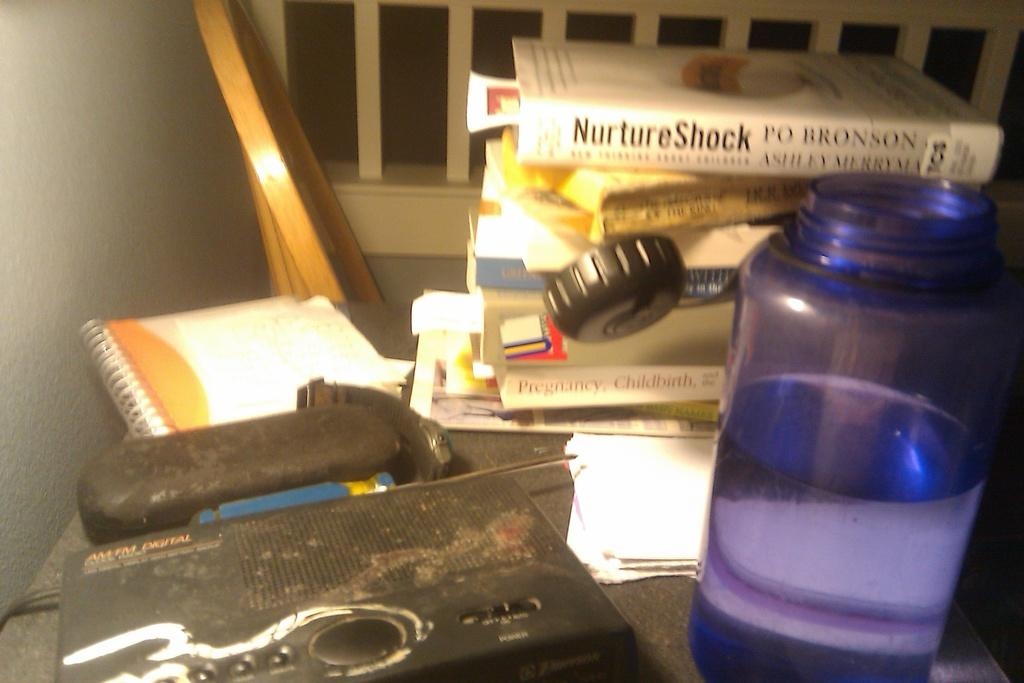<image>
Give a short and clear explanation of the subsequent image. The book on top of the others is titled "Nurture Shock". 